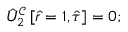<formula> <loc_0><loc_0><loc_500><loc_500>\hat { U } _ { 2 } ^ { \mathcal { C } } \left [ \hat { r } = 1 , \hat { \tau } \right ] = 0 ;</formula> 